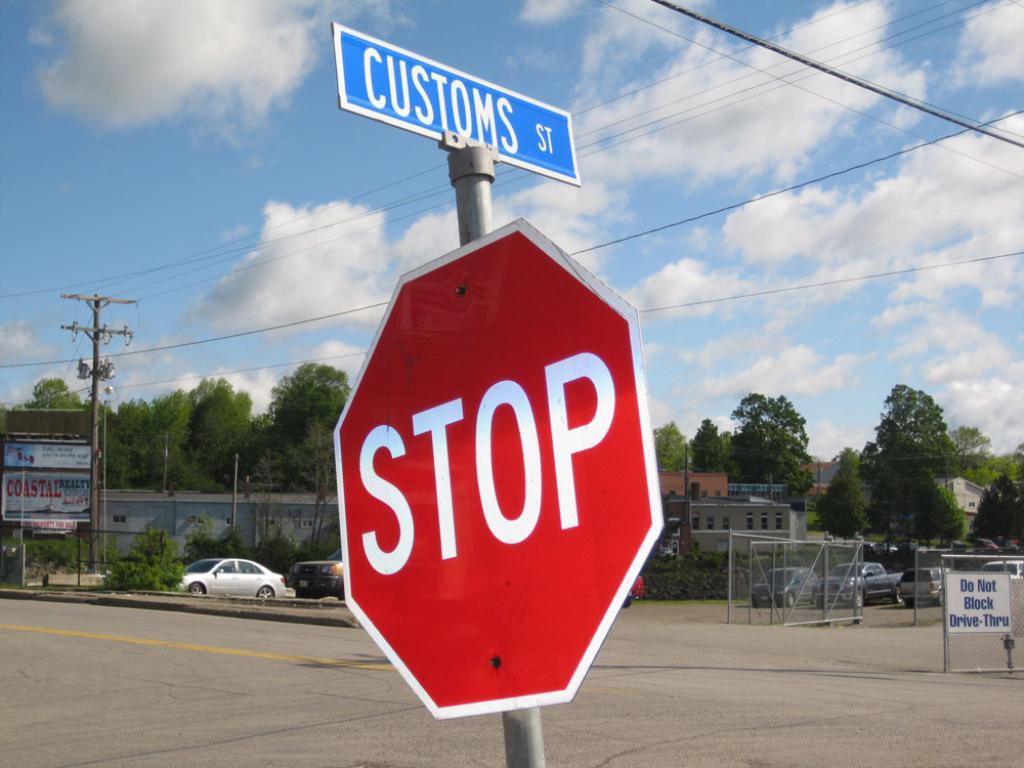<image>
Summarize the visual content of the image. a stop sign that is outside with customs above it 